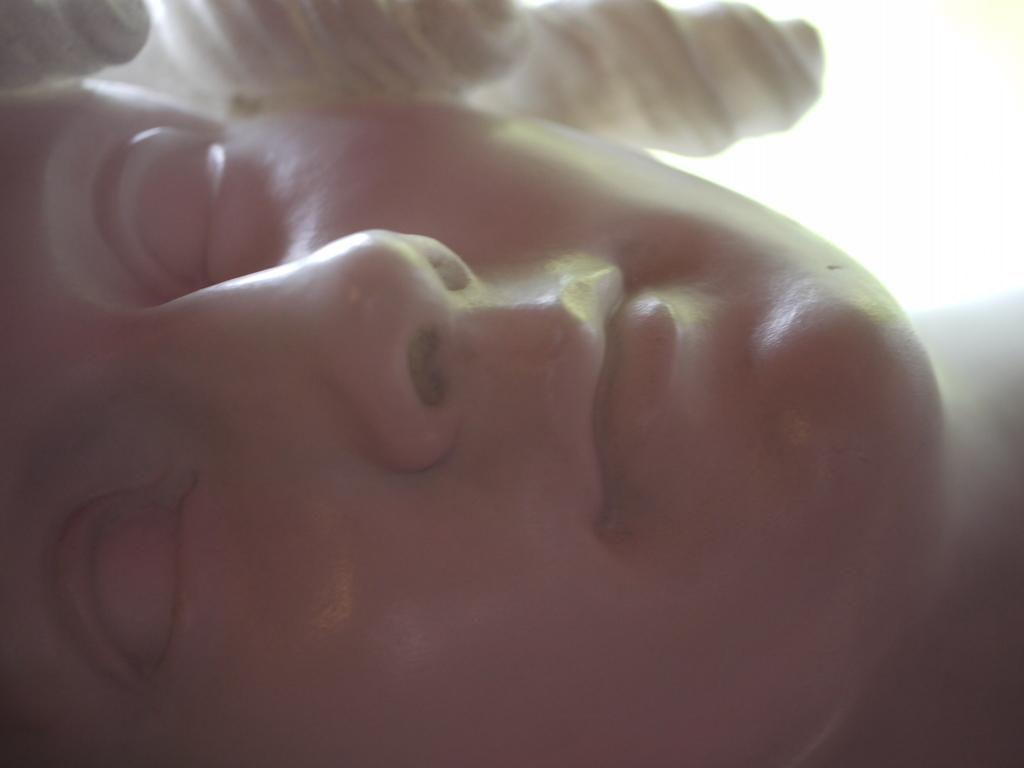What is the main subject of the image? The main subject of the image is a statue. Can you describe the statue in the image? The statue is of a woman's face. How many pets are sitting on the throne next to the statue in the image? There is no throne or pets present in the image; it only features a statue of a woman's face. 